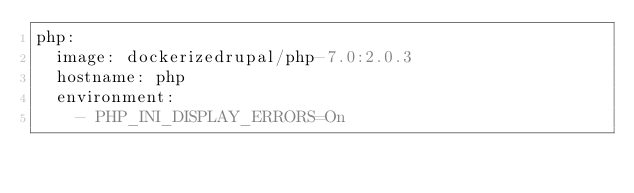<code> <loc_0><loc_0><loc_500><loc_500><_YAML_>php:
  image: dockerizedrupal/php-7.0:2.0.3
  hostname: php
  environment:
    - PHP_INI_DISPLAY_ERRORS=On
</code> 